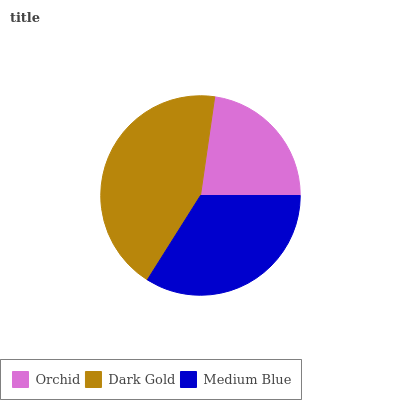Is Orchid the minimum?
Answer yes or no. Yes. Is Dark Gold the maximum?
Answer yes or no. Yes. Is Medium Blue the minimum?
Answer yes or no. No. Is Medium Blue the maximum?
Answer yes or no. No. Is Dark Gold greater than Medium Blue?
Answer yes or no. Yes. Is Medium Blue less than Dark Gold?
Answer yes or no. Yes. Is Medium Blue greater than Dark Gold?
Answer yes or no. No. Is Dark Gold less than Medium Blue?
Answer yes or no. No. Is Medium Blue the high median?
Answer yes or no. Yes. Is Medium Blue the low median?
Answer yes or no. Yes. Is Dark Gold the high median?
Answer yes or no. No. Is Orchid the low median?
Answer yes or no. No. 